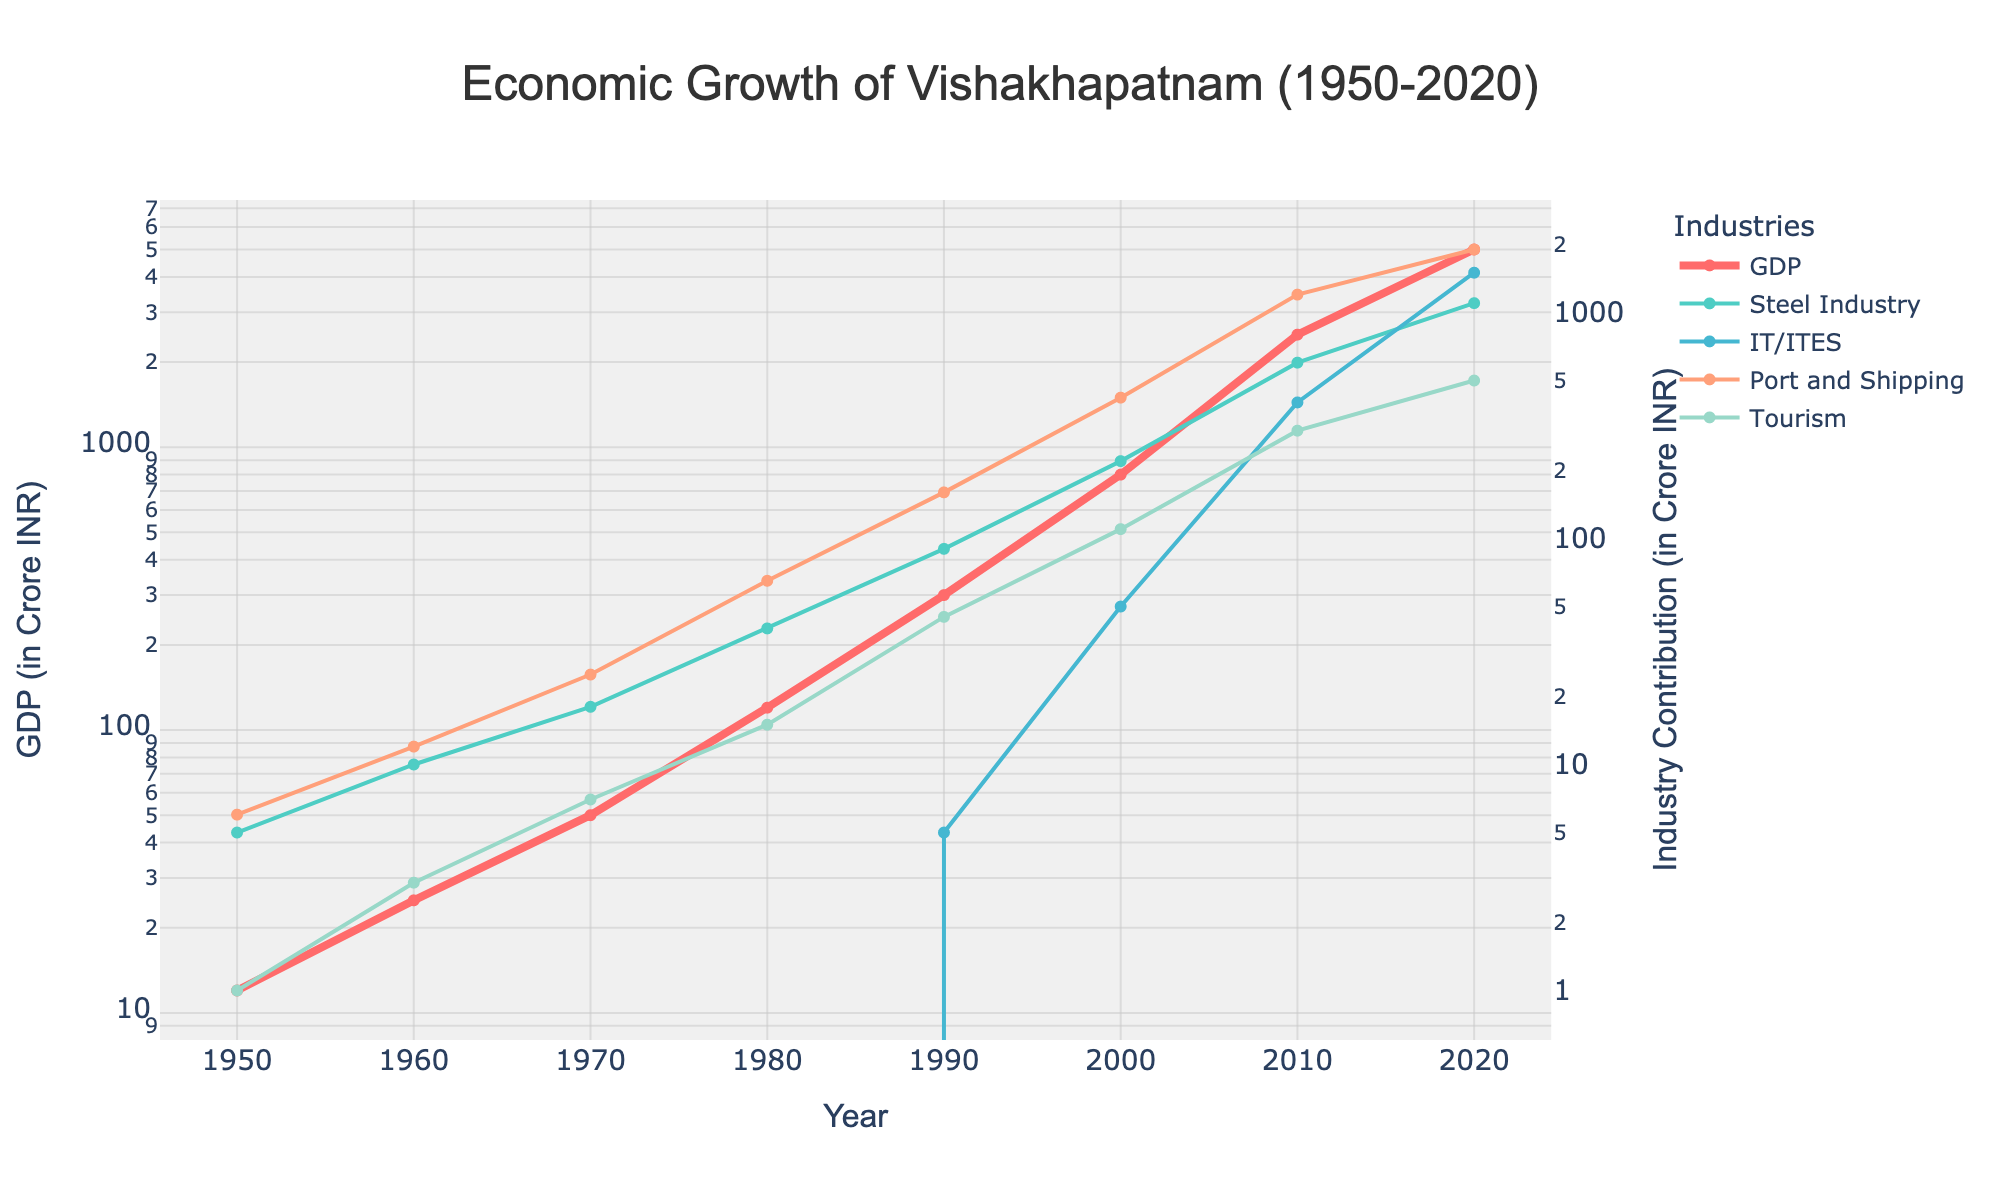What is the GDP of Vishakhapatnam in 1980? The GDP is represented by a red line on the chart. Find the value on the y-axis that corresponds to the year 1980.
Answer: 120 Crore INR Which industry had the highest contribution to Vishakhapatnam’s GDP in 2020? Look at the values of the different industry lines (Steel Industry, IT/ITES, Port and Shipping, Tourism) in the year 2020 and identify the highest value.
Answer: IT/ITES How much did the tourism industry contribute to GDP in 1990 compared to 1980? On the chart, locate the data points for the tourism industry for the years 1990 and 1980, subtract the value in 1980 from the value in 1990 to find the difference.
Answer: 30 Crore INR What is the trend of the IT/ITES industry from 2000 to 2020? Follow the IT/ITES line on the chart from the year 2000 to 2020 and describe the trend (increasing or decreasing).
Answer: Increasing Which year showed the first contribution of IT/ITES to the GDP? The first non-zero point of the IT/ITES industry line indicates the year when IT/ITES first contributed to GDP.
Answer: 1990 What was the combined contribution of the Steel Industry and Tourism in 1970? Locate the values of the Steel Industry and Tourism in 1970 and sum them up.
Answer: 25 Crore INR In which decade did the Port and Shipping industry see the most significant growth? Compare the differences in the Port and Shipping values between the consecutive decades and identify the one with the largest difference.
Answer: 1980s (1980-1990) What is the visual difference between the GDP growth and the Tourism industry growth? Observe the slopes and patterns of the GDP (red line) and the Tourism industry line on the chart, noting the differences.
Answer: GDP grows exponentially, Tourism grows steadily How did the Steel Industry contribution change from 1950 to 2020? Track the Steel Industry line from 1950 to 2020 and describe the change over time.
Answer: Increased significantly 